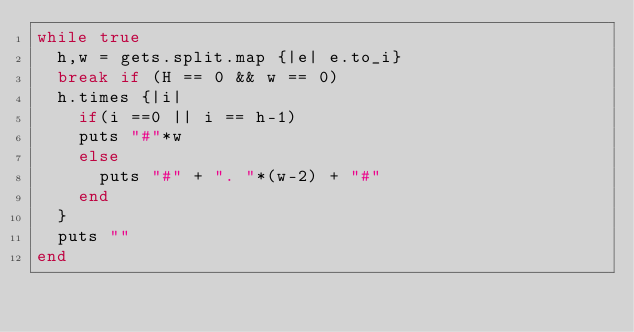Convert code to text. <code><loc_0><loc_0><loc_500><loc_500><_Ruby_>while true
  h,w = gets.split.map {|e| e.to_i}
  break if (H == 0 && w == 0)
  h.times {|i|
    if(i ==0 || i == h-1)
    puts "#"*w
    else
      puts "#" + ". "*(w-2) + "#"
    end
  }
  puts ""
end</code> 